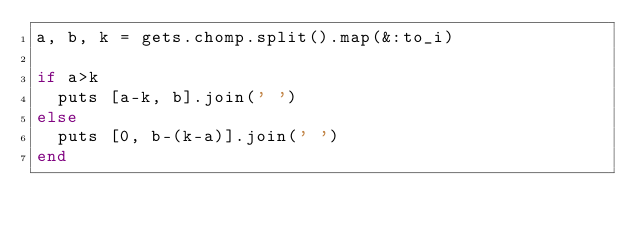Convert code to text. <code><loc_0><loc_0><loc_500><loc_500><_Ruby_>a, b, k = gets.chomp.split().map(&:to_i)

if a>k
  puts [a-k, b].join(' ')
else
  puts [0, b-(k-a)].join(' ')
end</code> 